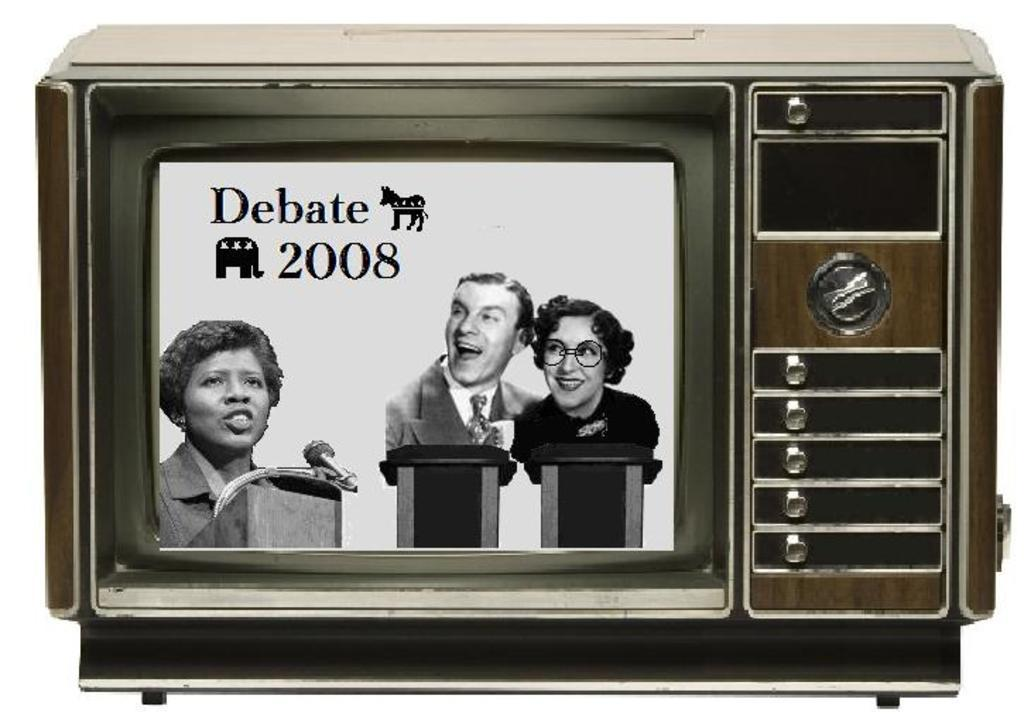Provide a one-sentence caption for the provided image. A TV screen mock up displays a Debate 2008 screen. 